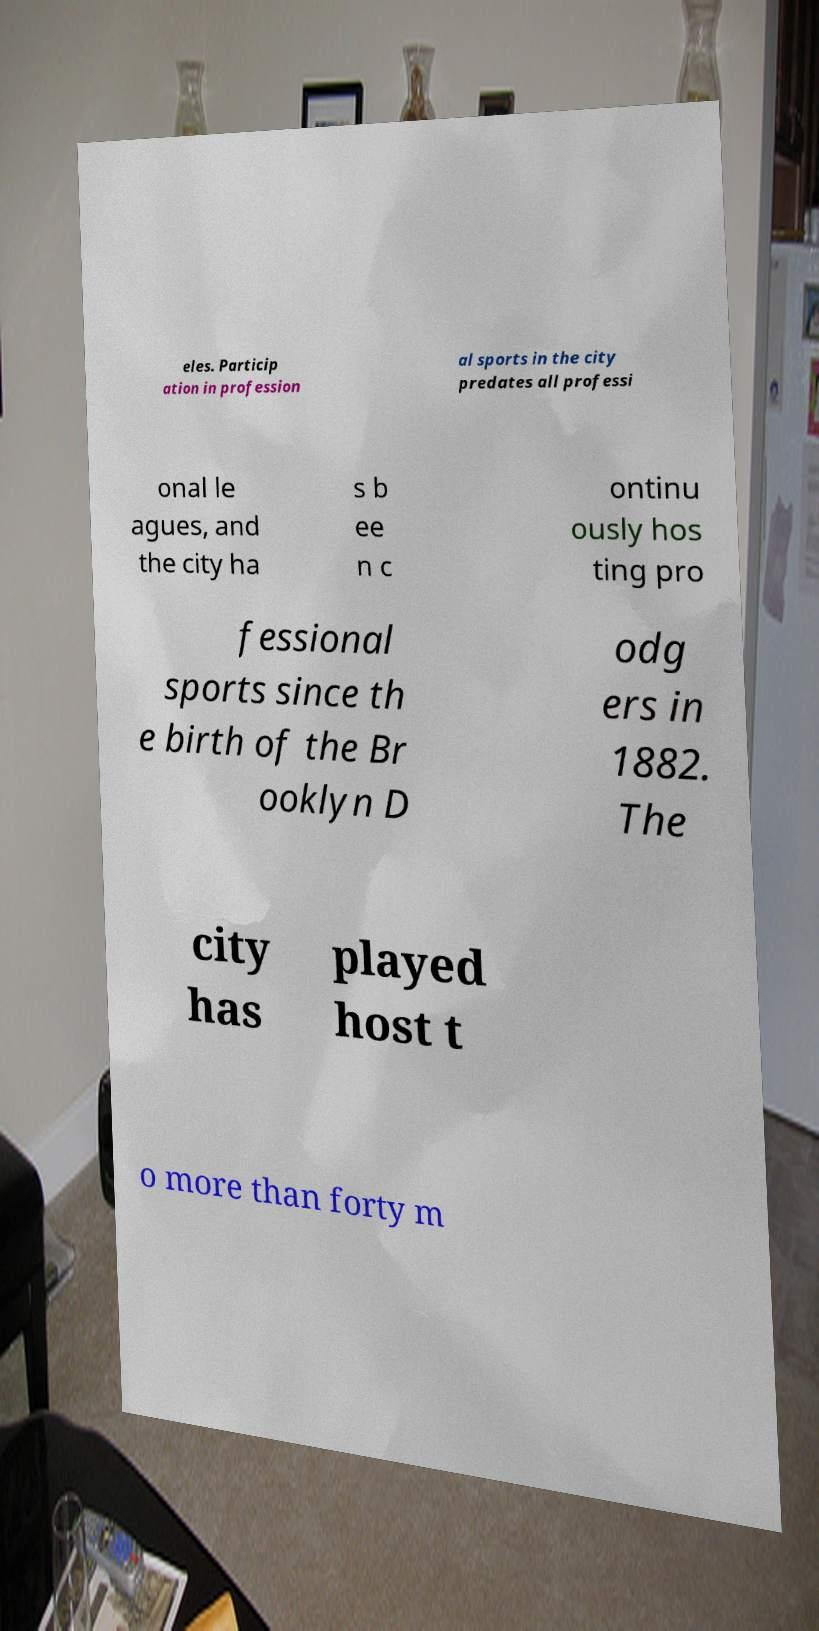I need the written content from this picture converted into text. Can you do that? eles. Particip ation in profession al sports in the city predates all professi onal le agues, and the city ha s b ee n c ontinu ously hos ting pro fessional sports since th e birth of the Br ooklyn D odg ers in 1882. The city has played host t o more than forty m 